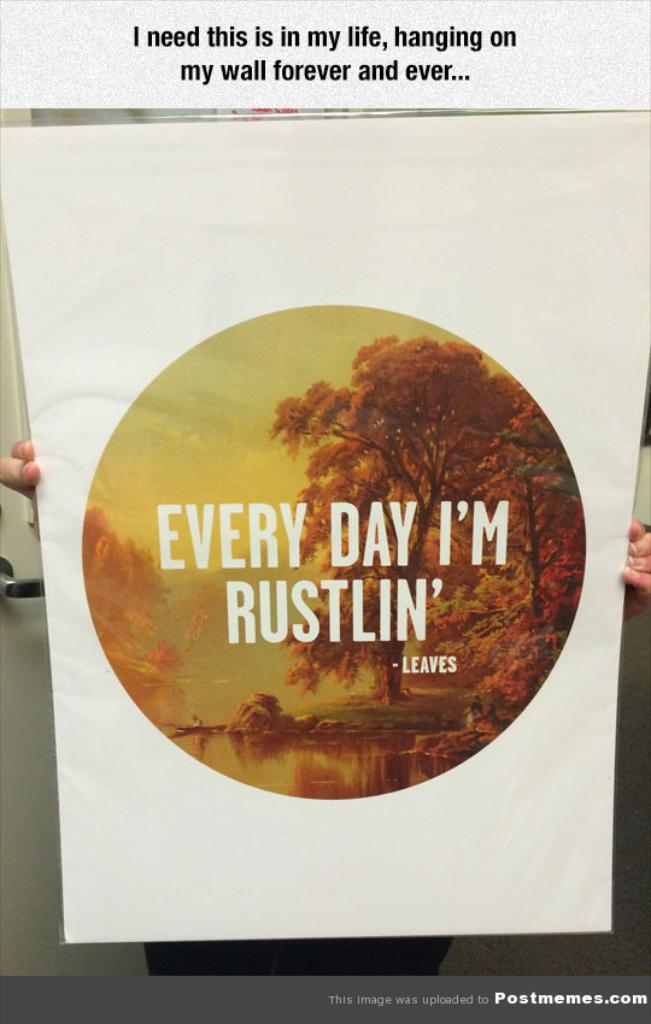<image>
Share a concise interpretation of the image provided. a poster says Every Day I'm Rustlin' written by Leaves 